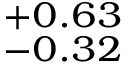<formula> <loc_0><loc_0><loc_500><loc_500>^ { + 0 . 6 3 } _ { - 0 . 3 2 }</formula> 